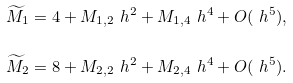<formula> <loc_0><loc_0><loc_500><loc_500>\widetilde { M } _ { 1 } & = 4 + M _ { 1 , 2 } \ h ^ { 2 } + M _ { 1 , 4 } \ h ^ { 4 } + O ( \ h ^ { 5 } ) , \\ \widetilde { M } _ { 2 } & = 8 + M _ { 2 , 2 } \ h ^ { 2 } + M _ { 2 , 4 } \ h ^ { 4 } + O ( \ h ^ { 5 } ) .</formula> 